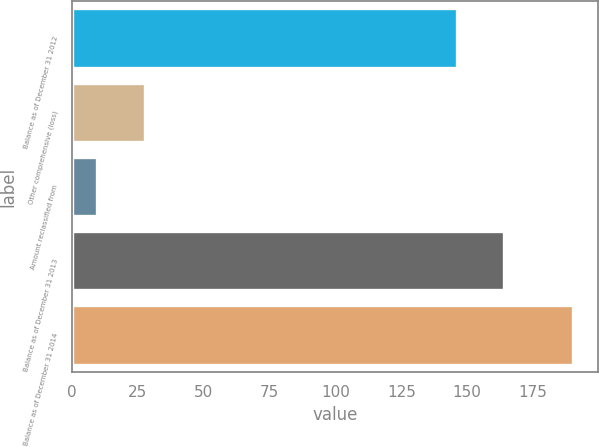<chart> <loc_0><loc_0><loc_500><loc_500><bar_chart><fcel>Balance as of December 31 2012<fcel>Other comprehensive (loss)<fcel>Amount reclassified from<fcel>Balance as of December 31 2013<fcel>Balance as of December 31 2014<nl><fcel>146<fcel>27.58<fcel>9.5<fcel>164.08<fcel>190.3<nl></chart> 